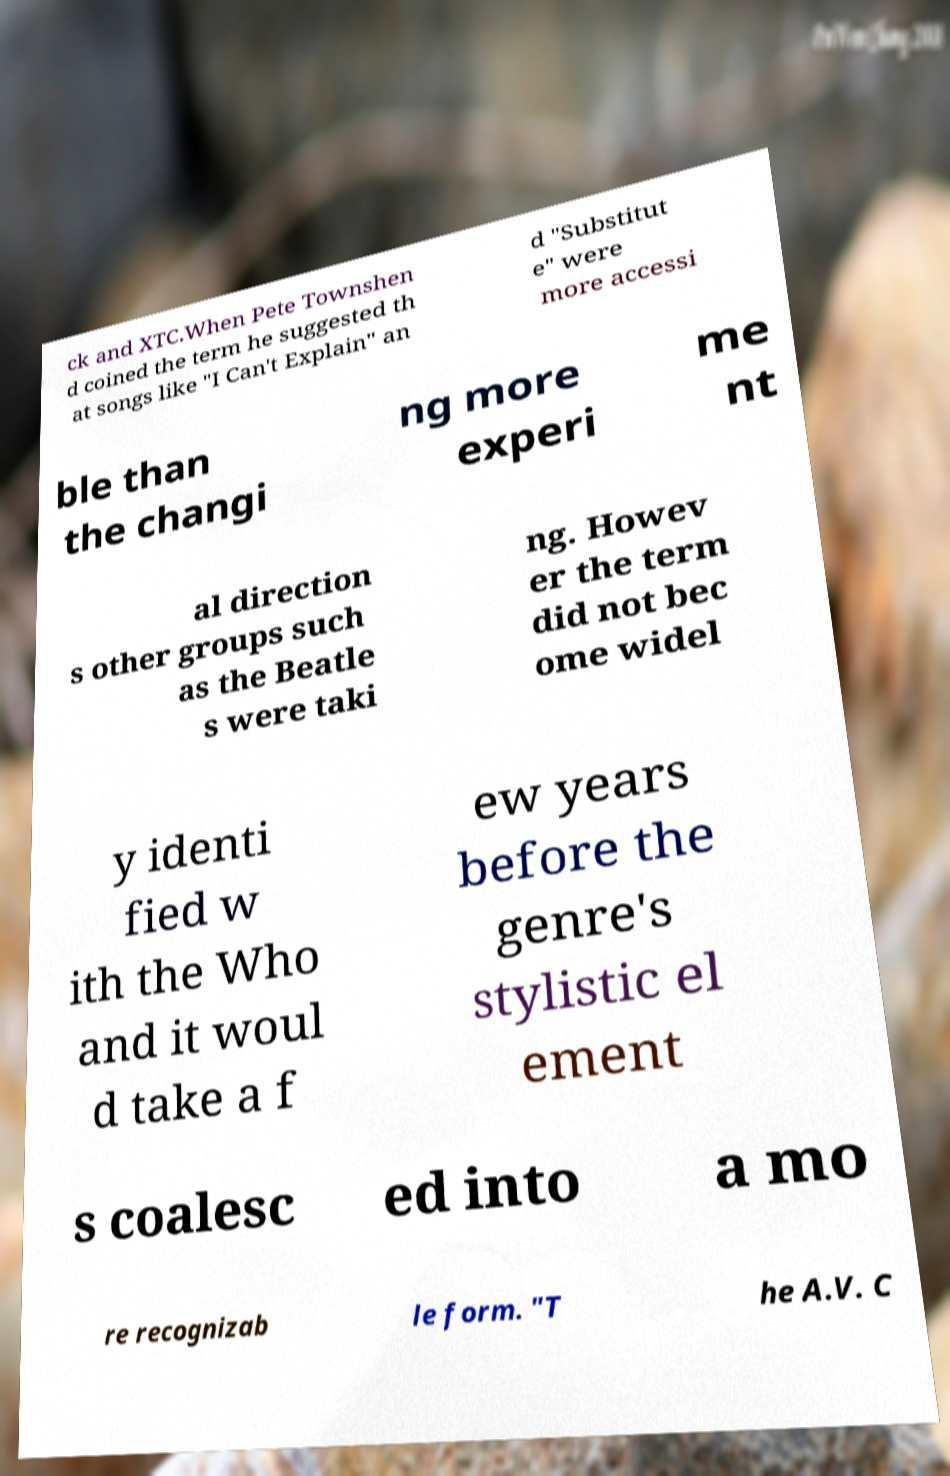There's text embedded in this image that I need extracted. Can you transcribe it verbatim? ck and XTC.When Pete Townshen d coined the term he suggested th at songs like "I Can't Explain" an d "Substitut e" were more accessi ble than the changi ng more experi me nt al direction s other groups such as the Beatle s were taki ng. Howev er the term did not bec ome widel y identi fied w ith the Who and it woul d take a f ew years before the genre's stylistic el ement s coalesc ed into a mo re recognizab le form. "T he A.V. C 